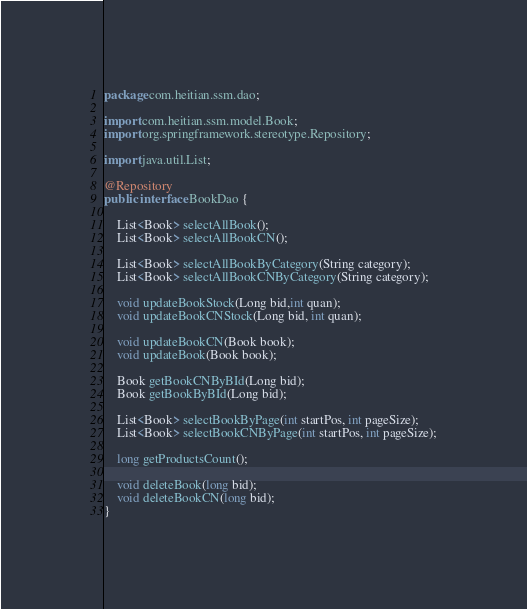Convert code to text. <code><loc_0><loc_0><loc_500><loc_500><_Java_>package com.heitian.ssm.dao;

import com.heitian.ssm.model.Book;
import org.springframework.stereotype.Repository;

import java.util.List;

@Repository
public interface BookDao {

    List<Book> selectAllBook();
    List<Book> selectAllBookCN();

    List<Book> selectAllBookByCategory(String category);
    List<Book> selectAllBookCNByCategory(String category);

    void updateBookStock(Long bid,int quan);
    void updateBookCNStock(Long bid, int quan);

    void updateBookCN(Book book);
    void updateBook(Book book);

    Book getBookCNByBId(Long bid);
    Book getBookByBId(Long bid);

    List<Book> selectBookByPage(int startPos, int pageSize);
    List<Book> selectBookCNByPage(int startPos, int pageSize);

    long getProductsCount();

    void deleteBook(long bid);
    void deleteBookCN(long bid);
}
</code> 